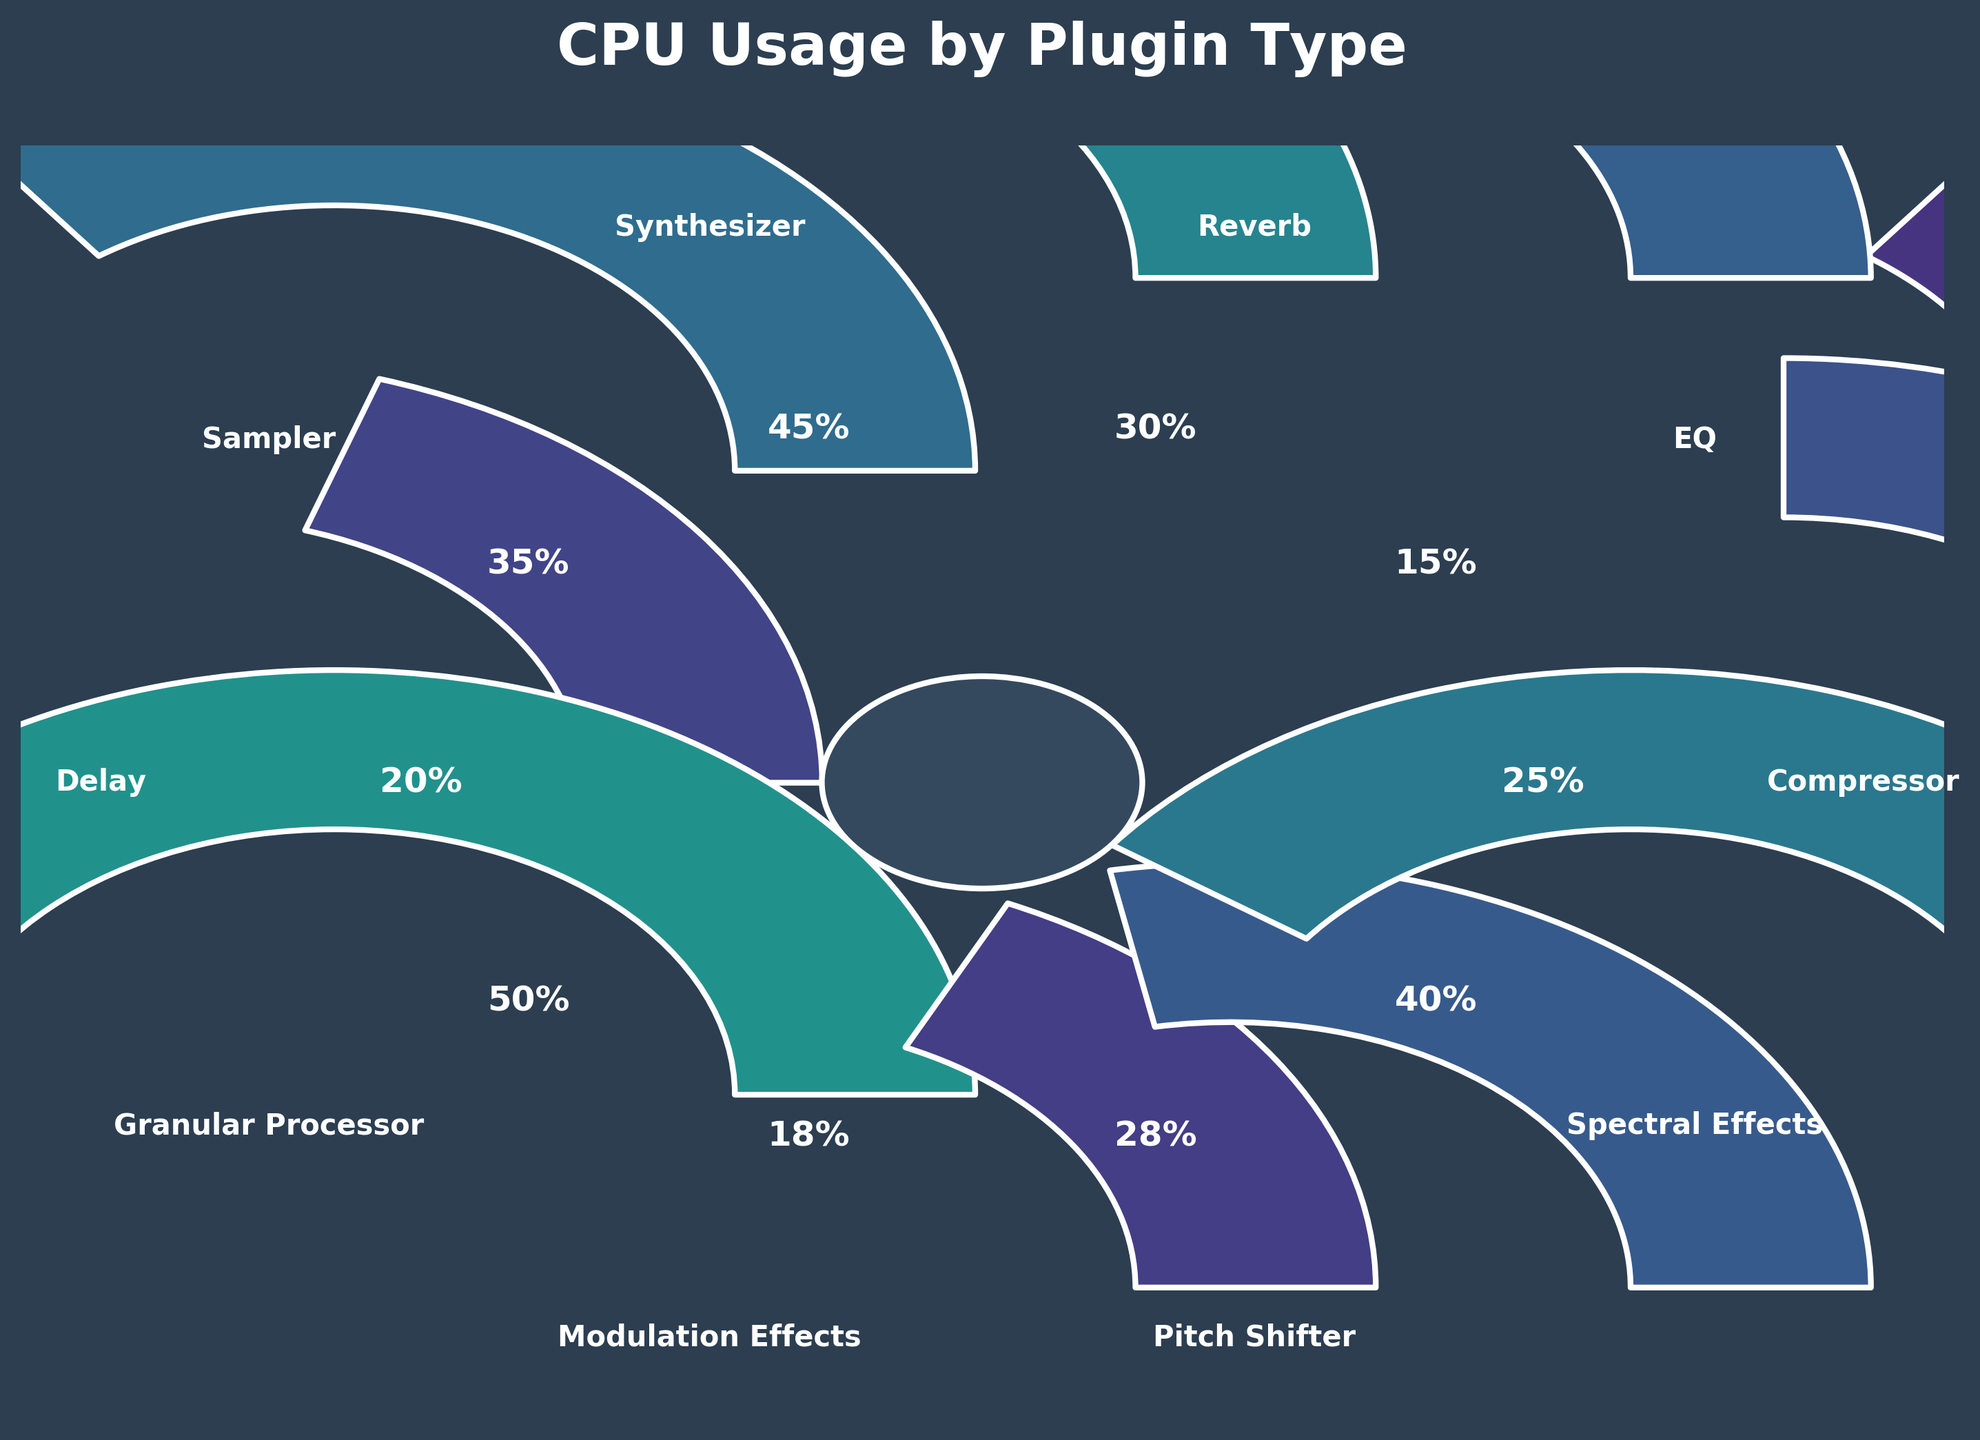What's the title of the figure? The title of the figure is written at the top of the plot. It reads "CPU Usage by Plugin Type".
Answer: CPU Usage by Plugin Type How many different plugin types are displayed in the figure? Count the number of unique plugin types displayed around the central circle. There are ten plugin types.
Answer: 10 Which plugin type has the highest CPU usage? Look for the gauge with the highest usage percentage near the edge. The Granular Processor shows a usage percentage of 50%.
Answer: Granular Processor What is the total CPU usage percentage of the plugins that use more than 30%? Identify all plugins with a usage percentage above 30%: Granular Processor (50%), Synthesizer (45%), Spectral Effects (40%), Sampler (35%), and Reverb (30%). Sum their percentages: 50 + 45 + 40 + 35 + 30 = 200.
Answer: 200 Which plugins use less than 20% CPU? Identify plugins with a usage percentage below 20%. These are EQ (15%) and Modulation Effects (18%).
Answer: EQ and Modulation Effects What's the difference in CPU usage between the Synthesizer and the Delay plugin? The Synthesizer uses 45% and the Delay uses 20%. The difference is 45 - 20 = 25%.
Answer: 25 Is there a plugin type that uses exactly 30% CPU? Look for a gauge showing exactly 30% CPU usage. The Reverb plugin uses exactly 30%.
Answer: Reverb What is the average CPU usage percentage of all plugin types displayed? Sum all CPU usages: 25 + 15 + 30 + 45 + 35 + 20 + 50 + 18 + 28 + 40 = 306. Divide by the number of plugins, which is 10. The average is 306 / 10 = 30.6%.
Answer: 30.6 Which plugin has higher CPU usage, the Delay or the Compressor? The Delay shows 20% usage, whereas the Compressor shows 25%. Therefore, the Compressor has higher CPU usage.
Answer: Compressor How much more CPU usage does the Granular Processor have compared to the Spectral Effects? The Granular Processor has 50% usage, and Spectral Effects has 40%. The difference is 50 - 40 = 10%.
Answer: 10 